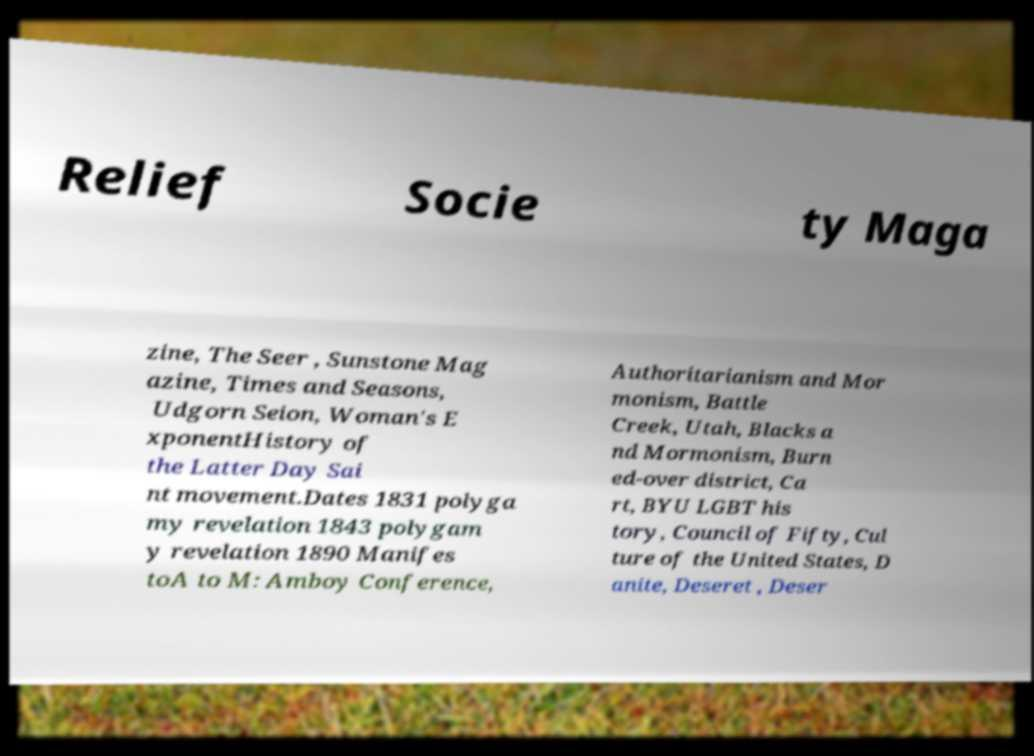Please read and relay the text visible in this image. What does it say? Relief Socie ty Maga zine, The Seer , Sunstone Mag azine, Times and Seasons, Udgorn Seion, Woman's E xponentHistory of the Latter Day Sai nt movement.Dates 1831 polyga my revelation 1843 polygam y revelation 1890 Manifes toA to M: Amboy Conference, Authoritarianism and Mor monism, Battle Creek, Utah, Blacks a nd Mormonism, Burn ed-over district, Ca rt, BYU LGBT his tory, Council of Fifty, Cul ture of the United States, D anite, Deseret , Deser 